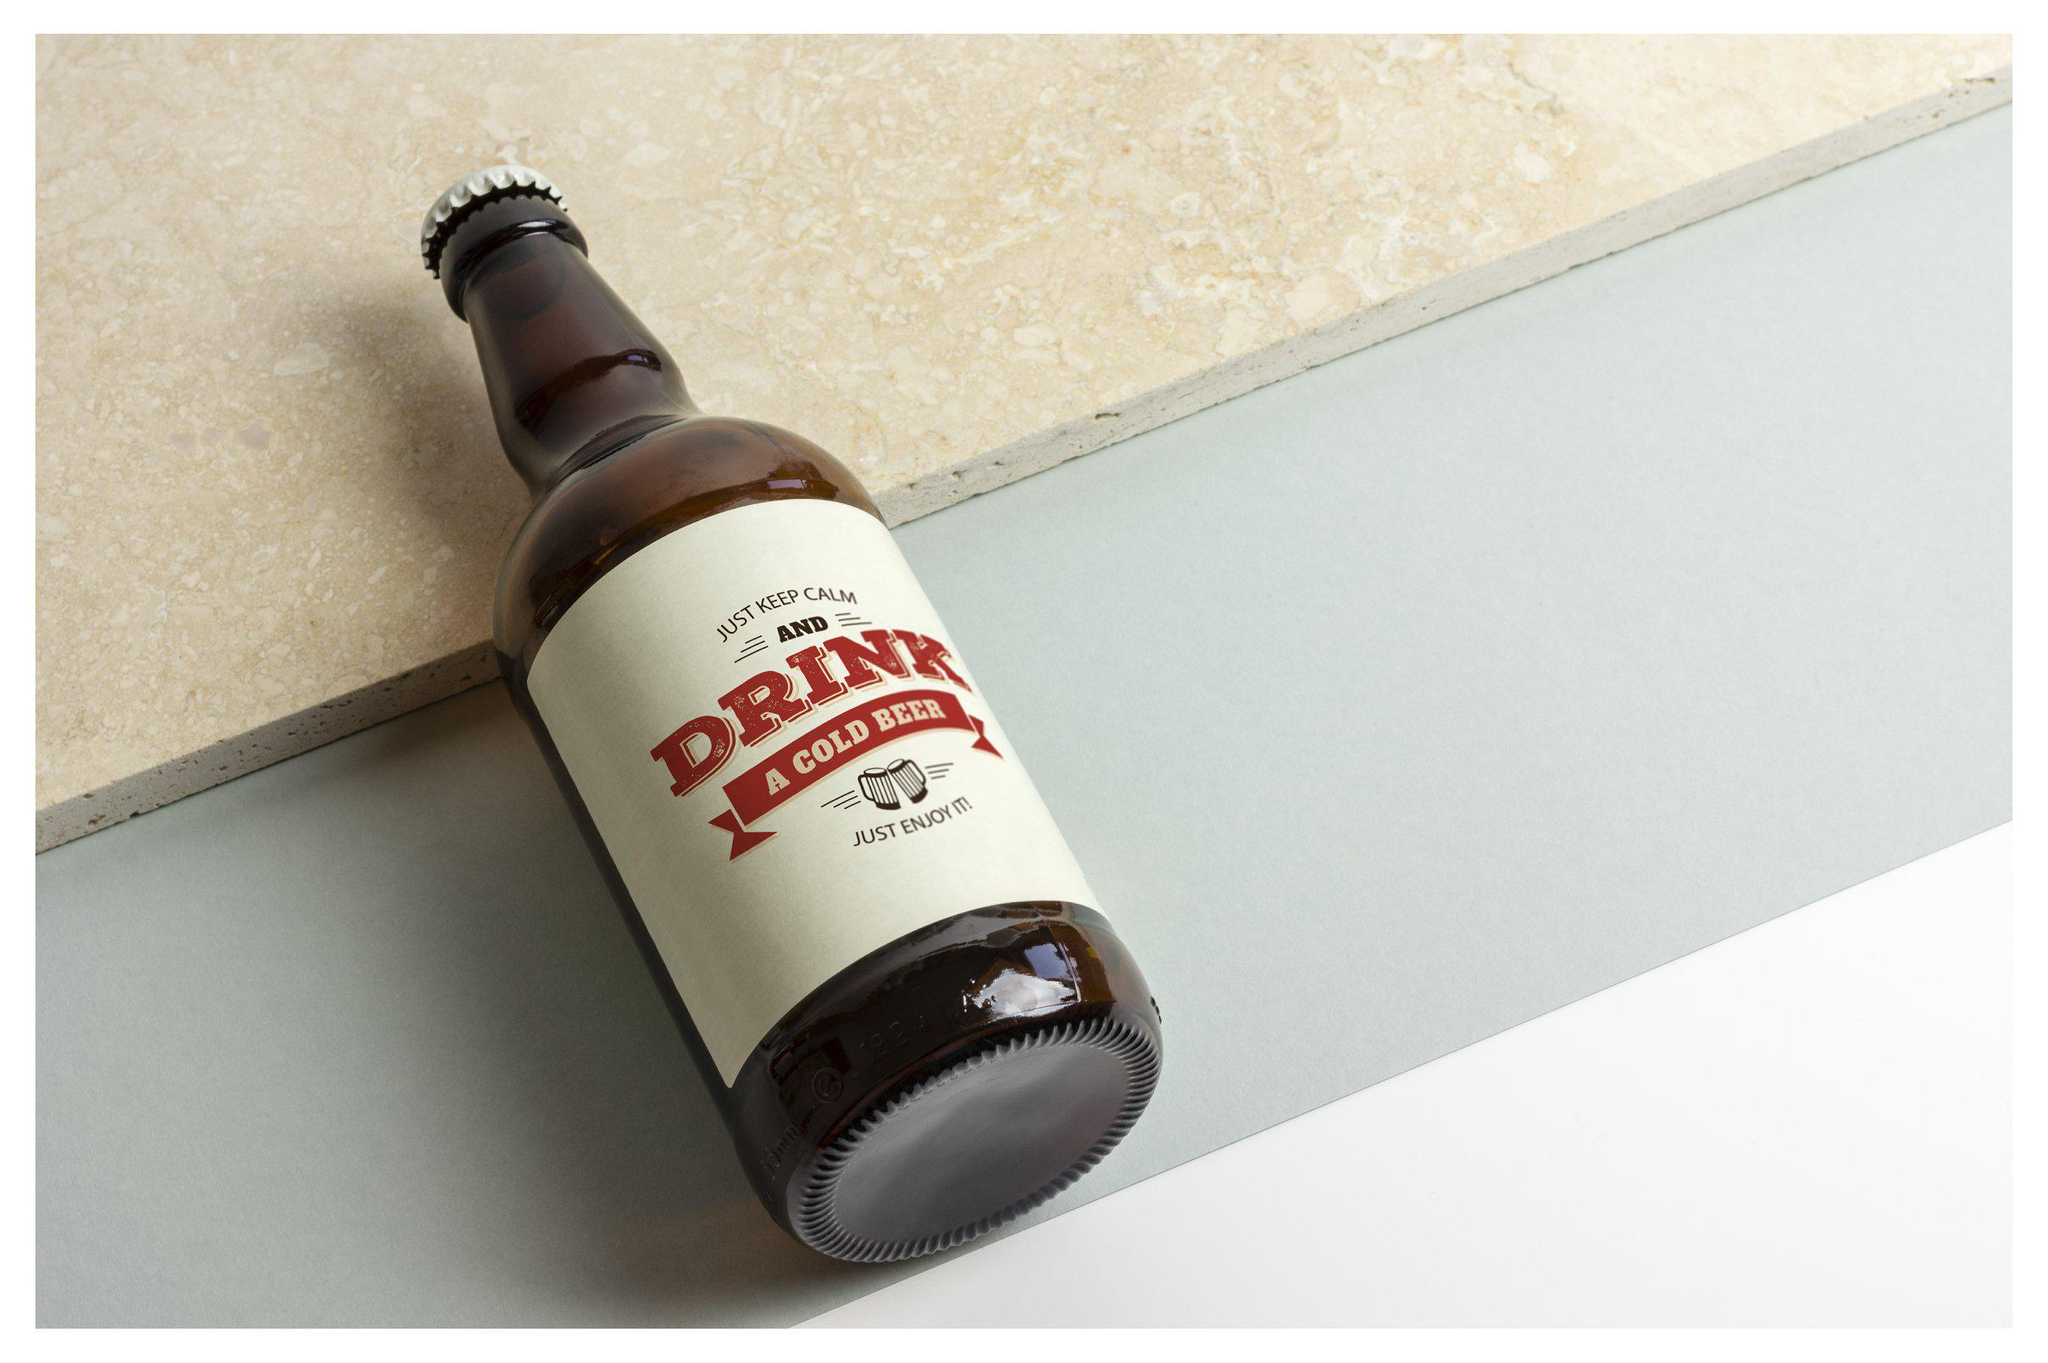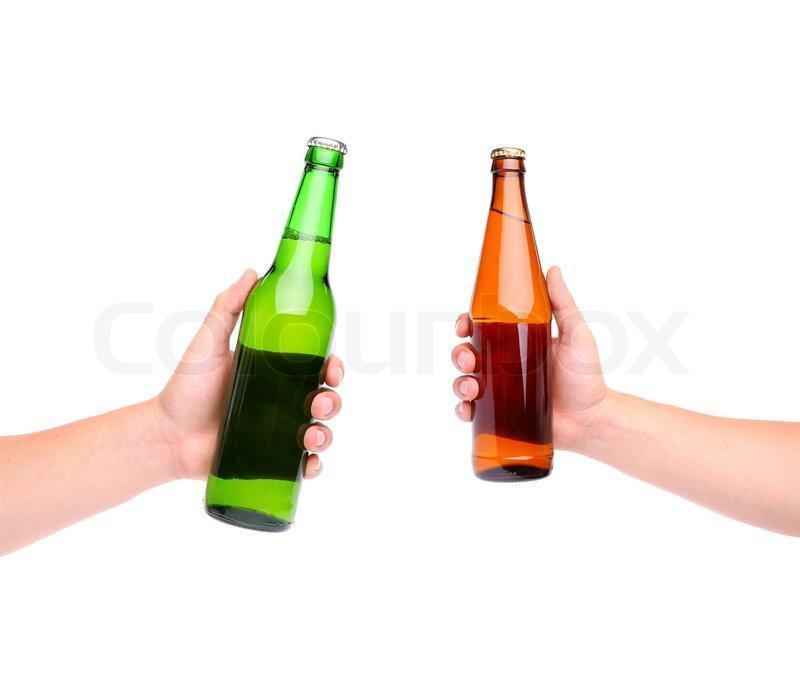The first image is the image on the left, the second image is the image on the right. Given the left and right images, does the statement "In one image there is one green bottle with one brown bottle" hold true? Answer yes or no. Yes. The first image is the image on the left, the second image is the image on the right. Examine the images to the left and right. Is the description "An image shows exactly two bottles, one of them green." accurate? Answer yes or no. Yes. The first image is the image on the left, the second image is the image on the right. For the images displayed, is the sentence "There is a green bottle in one of the images." factually correct? Answer yes or no. Yes. The first image is the image on the left, the second image is the image on the right. Evaluate the accuracy of this statement regarding the images: "There is exactly one green bottle in one of the images.". Is it true? Answer yes or no. Yes. 